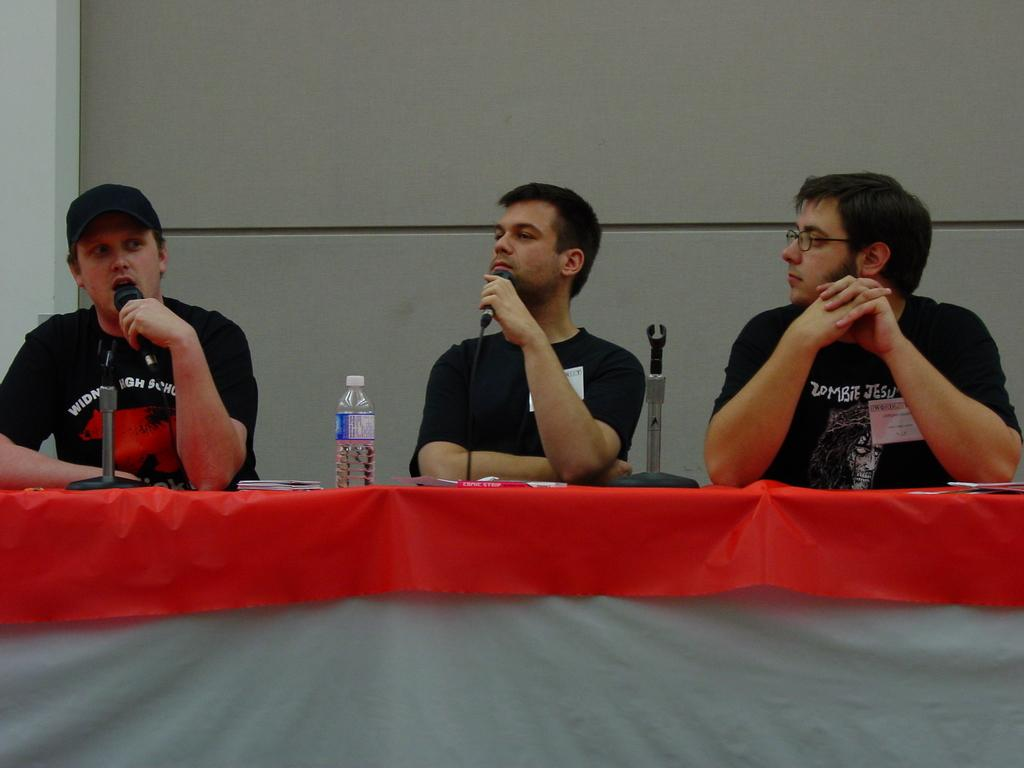How many people are in the image? There are three people in the image. What are the people doing in the image? The people are sitting on a chair. What is present on the table in the image? There is a bottle and a microphone on the table. Where are the kittens playing in the image? There are no kittens present in the image. Can you tell me how many floors the lift goes up to in the image? There is no lift present in the image. 